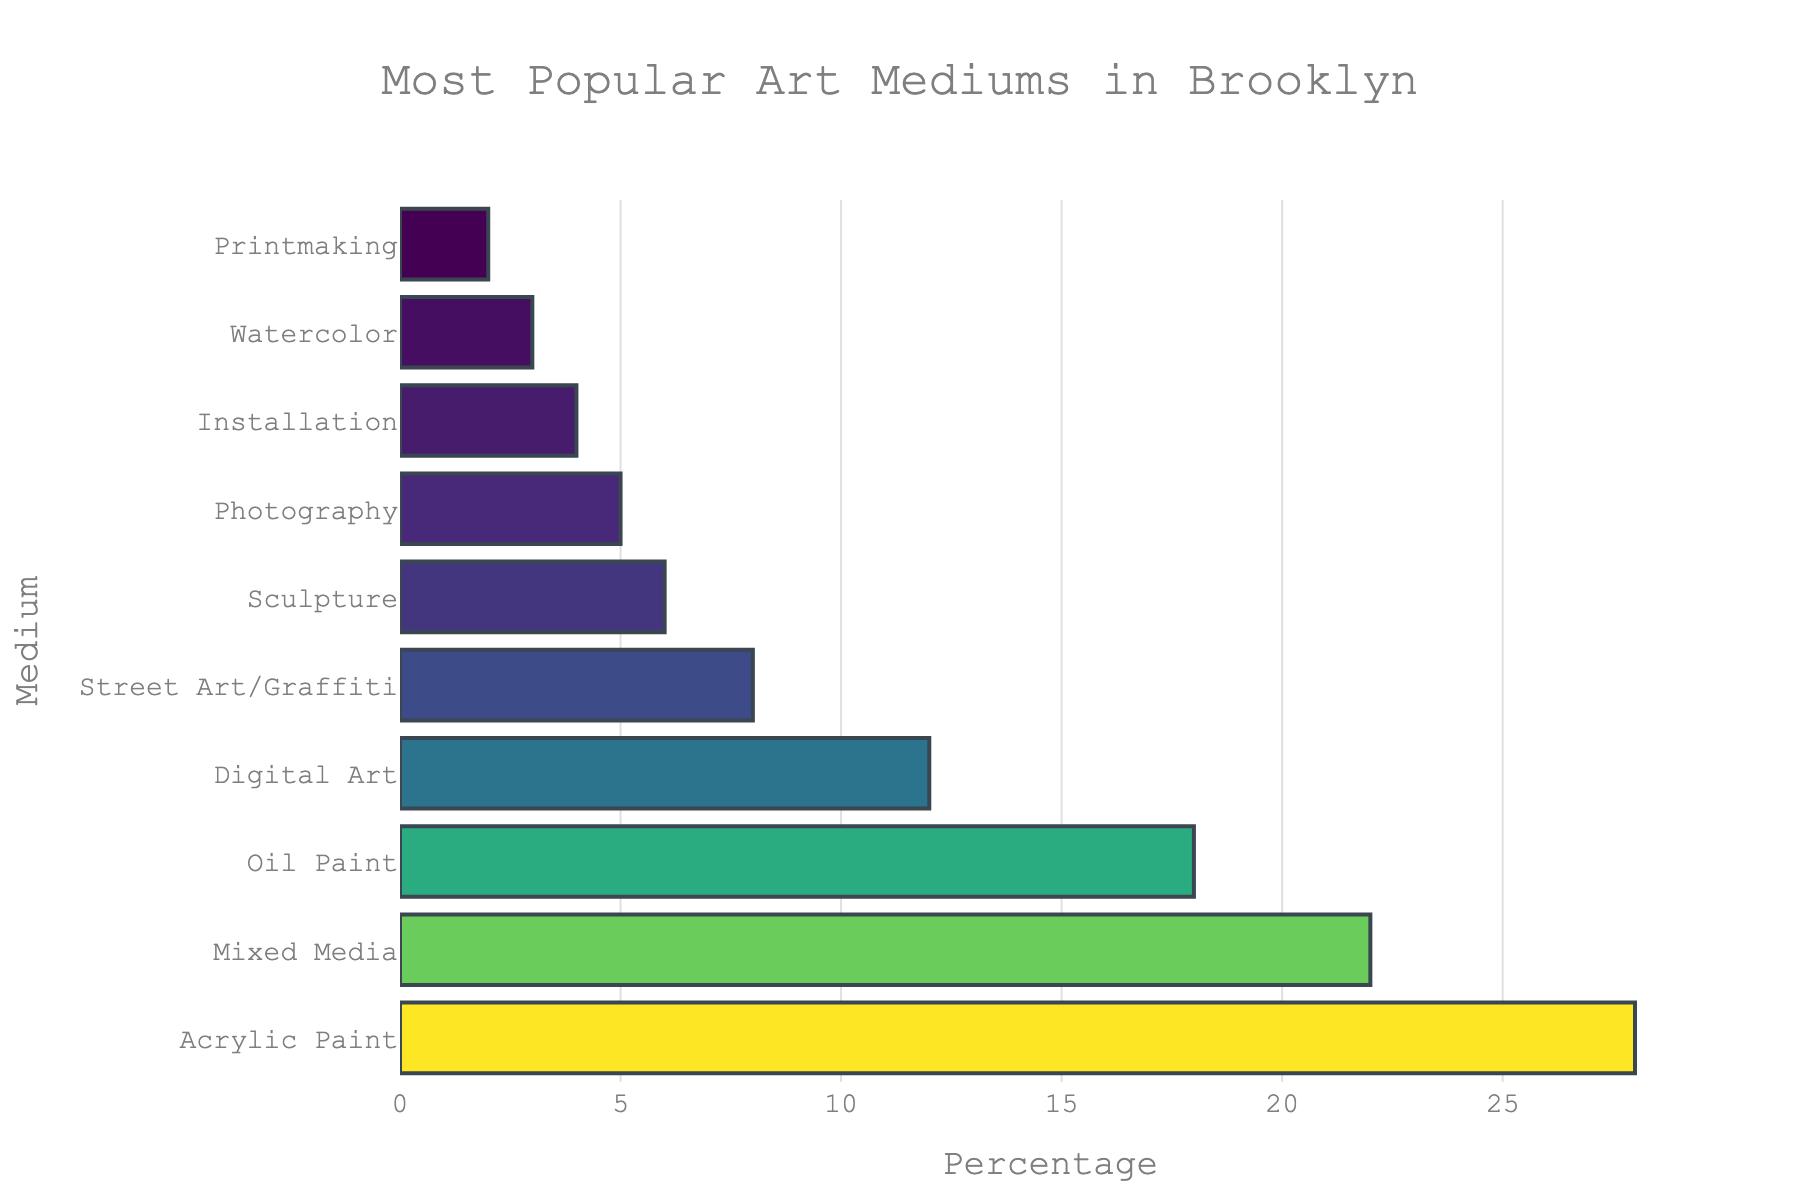Which art medium is the most popular in Brooklyn? The bar chart title mentions the figure represents the most popular art mediums in Brooklyn, and the bar with the highest percentage indicates "Acrylic Paint".
Answer: Acrylic Paint Which two art mediums have the smallest percentage in popularity? By looking at the lengths of the bars, the shortest bars for the smallest percentages correspond to "Printmaking" and "Watercolor".
Answer: Printmaking, Watercolor What is the combined popularity percentage of Sculpture and Photography? According to the chart, the percentage for Sculpture is 6 and for Photography is 5. Adding these two percentages: 6 + 5 = 11.
Answer: 11 By how much is Acrylic Paint more popular than Digital Art? The percentage for Acrylic Paint is 28, and for Digital Art, it is 12. The difference is 28 - 12 = 16.
Answer: 16 Between Mixed Media and Oil Paint, which medium has a higher percentage and by how much? Mixed Media has a percentage of 22, and Oil Paint has 18. Mixed Media is higher by the difference: 22 - 18 = 4.
Answer: Mixed Media, 4 Which art medium comes immediately after Oil Paint in terms of popularity percentage? The bar immediately shorter than Oil Paint's corresponds to "Digital Art" with 12%.
Answer: Digital Art How does the popularity of Street Art/Graffiti compare to Sculpture? Street Art/Graffiti has a percentage of 8, while Sculpture has 6. Street Art/Graffiti is more popular.
Answer: Street Art/Graffiti What is the cumulative percentage of the three least popular art mediums? The three least popular mediums are Printmaking (2), Watercolor (3), and Installation (4). Adding these up: 2 + 3 + 4 = 9.
Answer: 9 What are the visual characteristics of the most popular medium's bar? The bar for the most popular medium (Acrylic Paint) is the longest and is colored at the highest point of the colorscale applied.
Answer: Longest, highest point of colorscale 